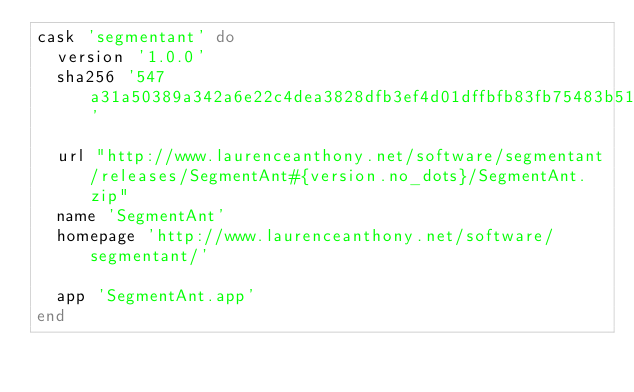Convert code to text. <code><loc_0><loc_0><loc_500><loc_500><_Ruby_>cask 'segmentant' do
  version '1.0.0'
  sha256 '547a31a50389a342a6e22c4dea3828dfb3ef4d01dffbfb83fb75483b514c16d4'

  url "http://www.laurenceanthony.net/software/segmentant/releases/SegmentAnt#{version.no_dots}/SegmentAnt.zip"
  name 'SegmentAnt'
  homepage 'http://www.laurenceanthony.net/software/segmentant/'

  app 'SegmentAnt.app'
end
</code> 